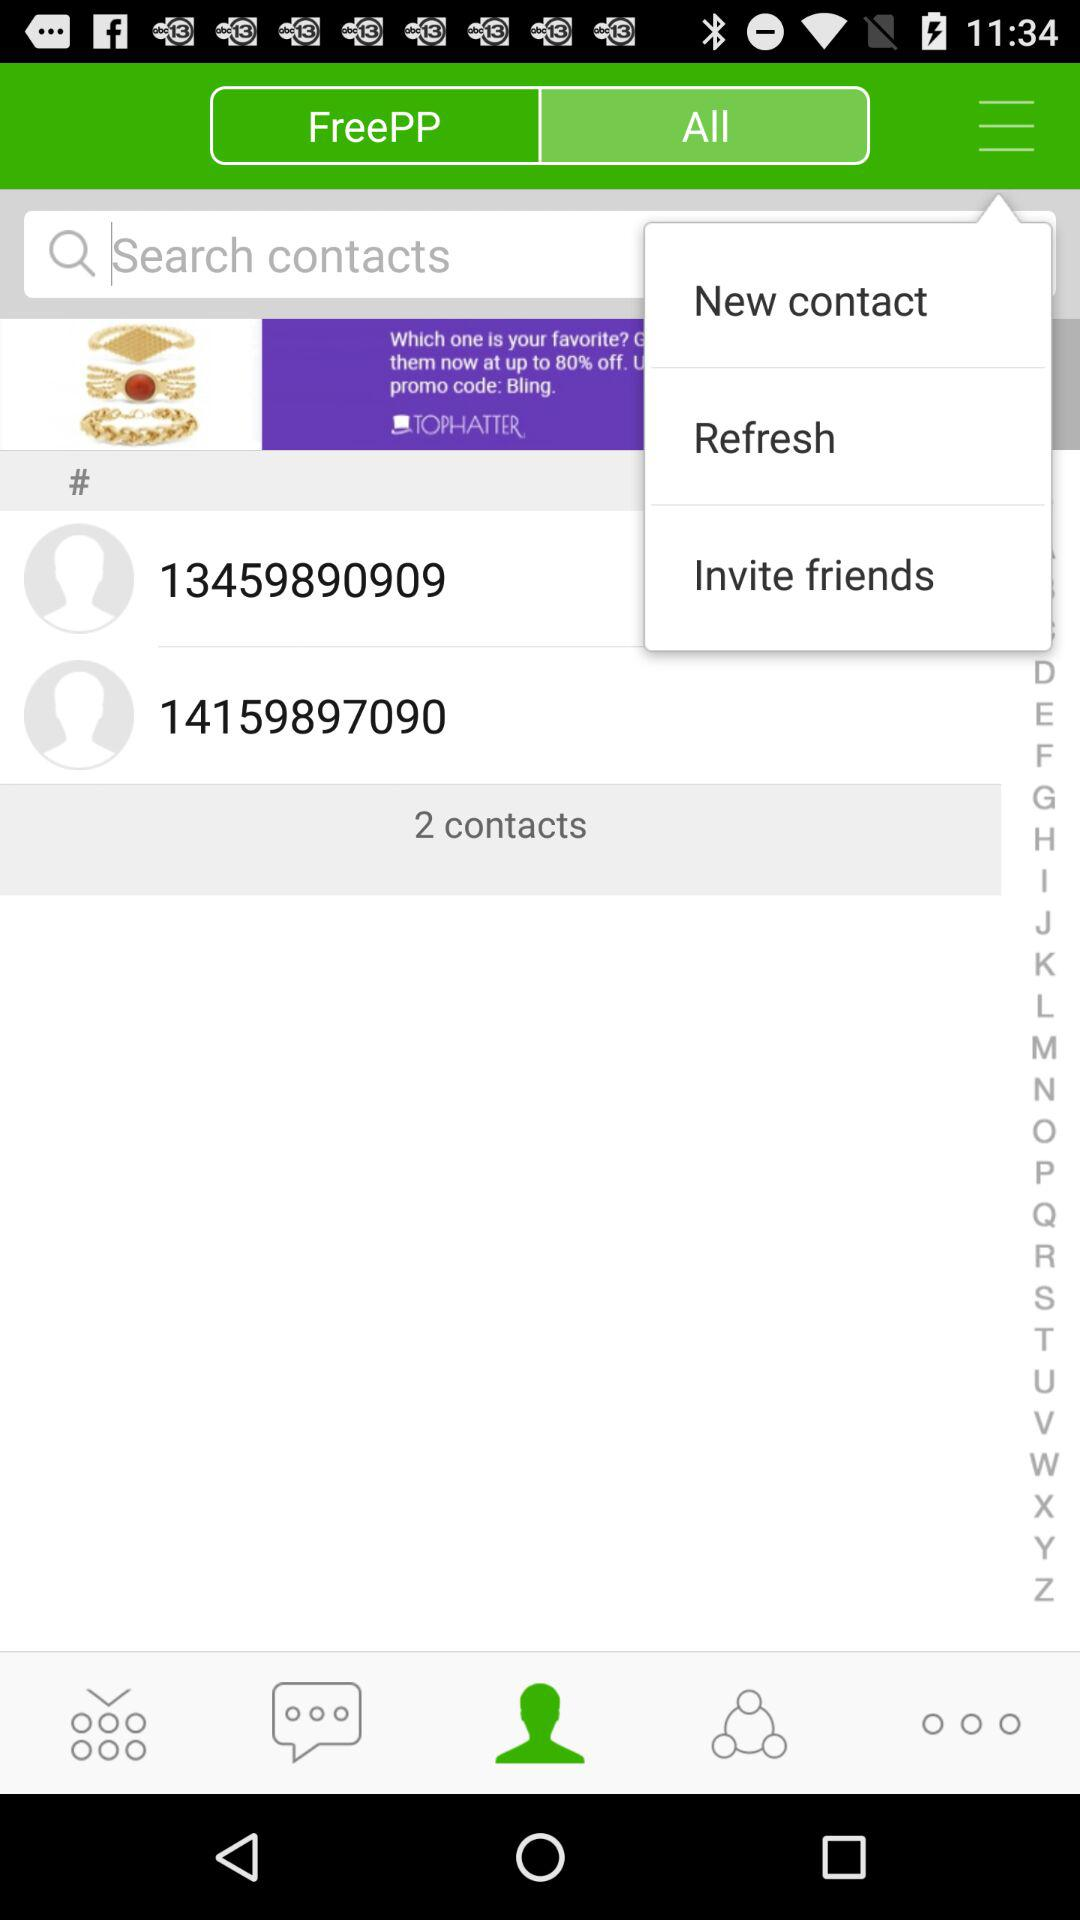What is the number of contacts do I have? You have two contacts. 